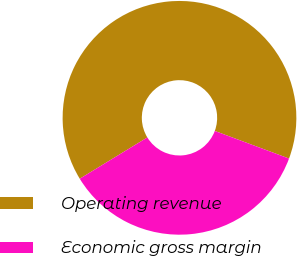Convert chart. <chart><loc_0><loc_0><loc_500><loc_500><pie_chart><fcel>Operating revenue<fcel>Economic gross margin<nl><fcel>64.39%<fcel>35.61%<nl></chart> 